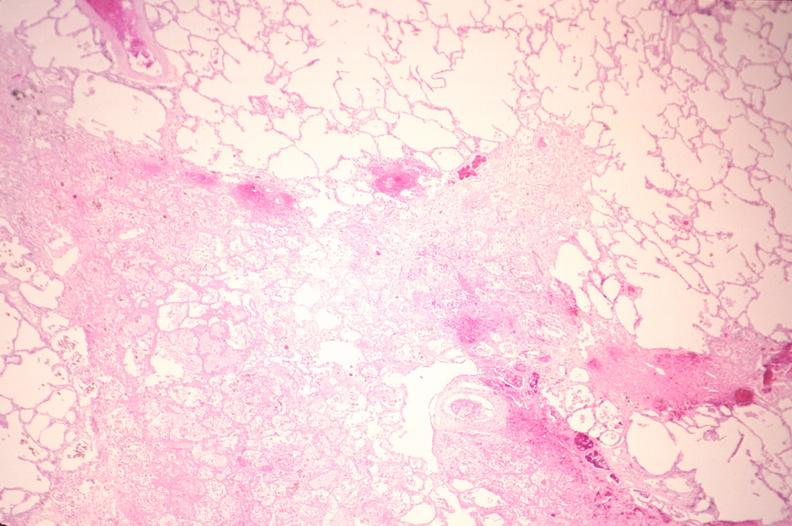does this image show lung, infarct, acute and organized?
Answer the question using a single word or phrase. Yes 